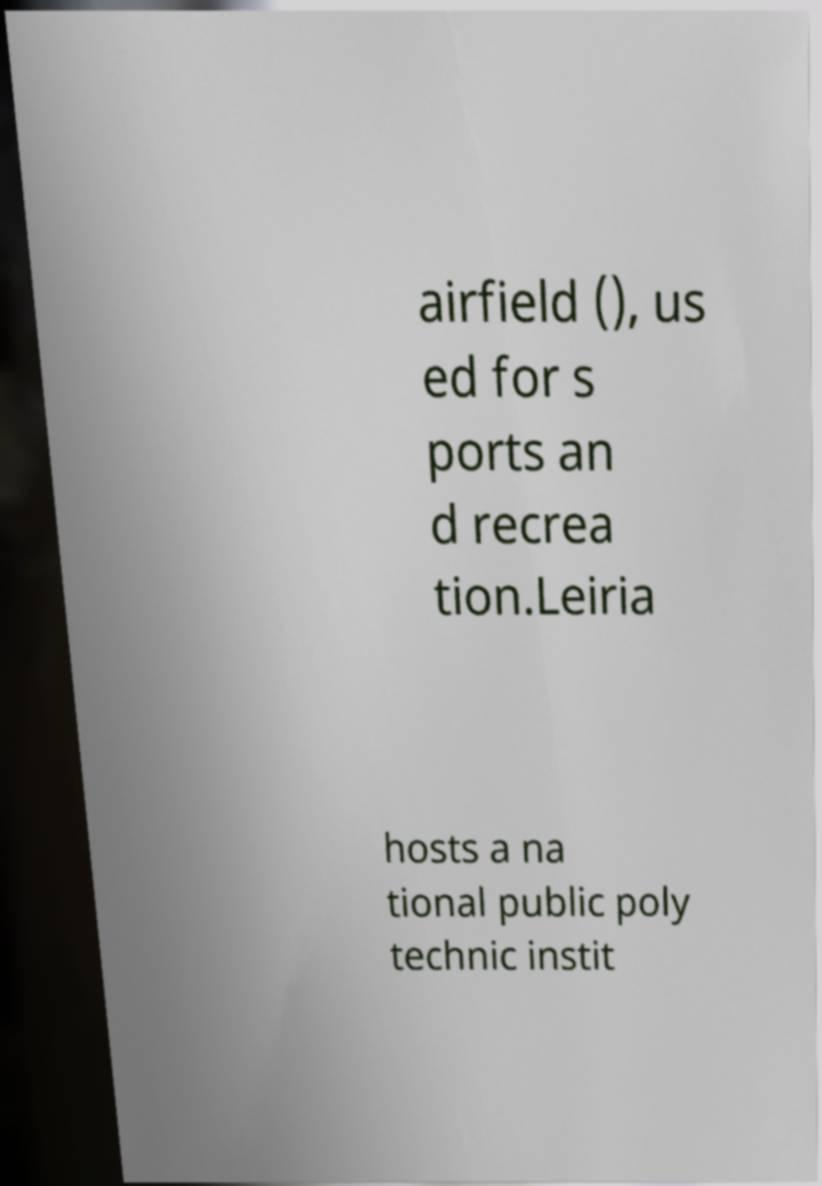Please identify and transcribe the text found in this image. airfield (), us ed for s ports an d recrea tion.Leiria hosts a na tional public poly technic instit 